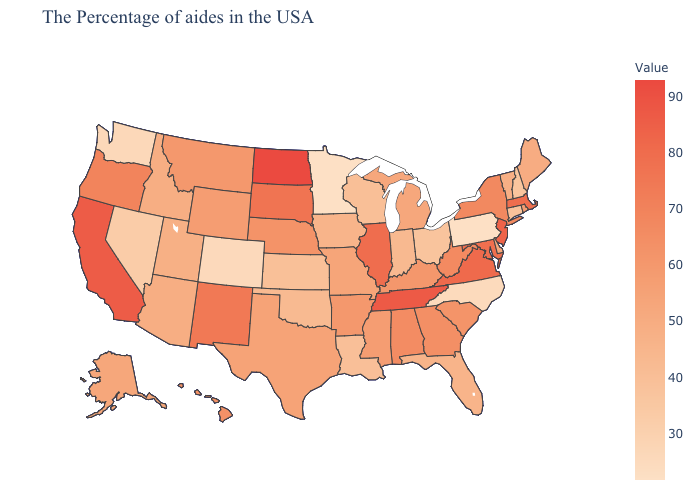Among the states that border Pennsylvania , does New Jersey have the highest value?
Write a very short answer. Yes. Does the map have missing data?
Short answer required. No. Does Missouri have the highest value in the MidWest?
Keep it brief. No. 